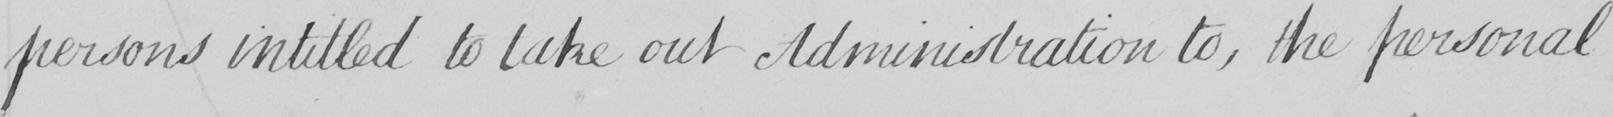Can you tell me what this handwritten text says? persons intitled to take out Administration to, the personal 